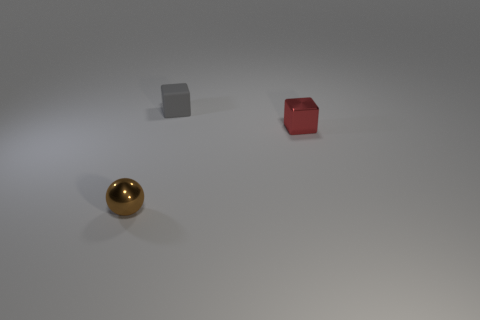Are there any other things that have the same shape as the red thing?
Make the answer very short. Yes. Is the number of big shiny cylinders greater than the number of rubber blocks?
Keep it short and to the point. No. How many other brown balls have the same size as the sphere?
Make the answer very short. 0. Is the material of the tiny gray block the same as the cube that is in front of the gray object?
Make the answer very short. No. Is the number of brown things less than the number of gray cylinders?
Offer a very short reply. No. Is there anything else that has the same color as the small matte block?
Your answer should be very brief. No. The tiny brown thing that is made of the same material as the small red block is what shape?
Provide a succinct answer. Sphere. What number of things are to the left of the tiny cube left of the tiny object on the right side of the tiny matte thing?
Your answer should be very brief. 1. The tiny object that is on the right side of the small brown object and in front of the small gray cube has what shape?
Make the answer very short. Cube. Are there fewer tiny gray matte things on the left side of the small brown sphere than cylinders?
Provide a succinct answer. No. 